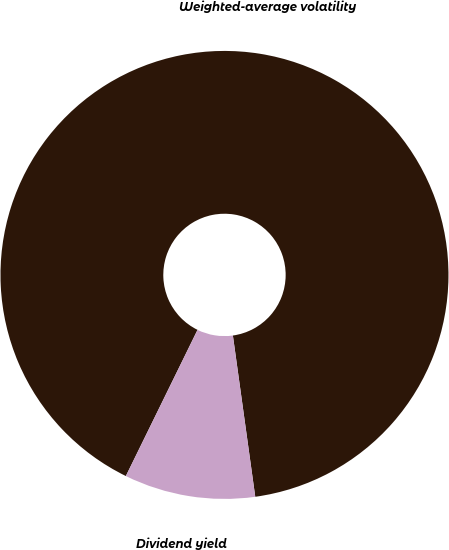Convert chart to OTSL. <chart><loc_0><loc_0><loc_500><loc_500><pie_chart><fcel>Weighted-average volatility<fcel>Dividend yield<nl><fcel>90.55%<fcel>9.45%<nl></chart> 